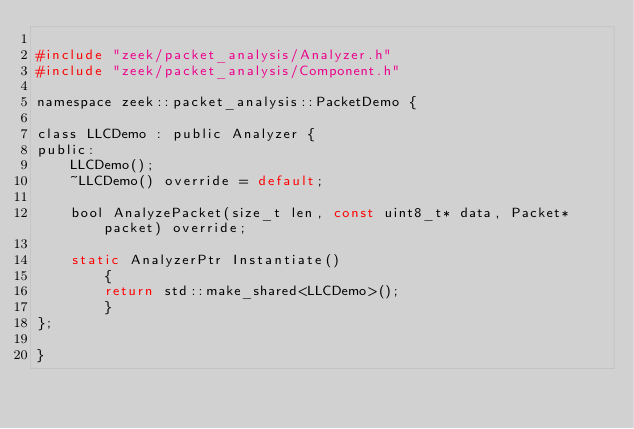Convert code to text. <code><loc_0><loc_0><loc_500><loc_500><_C_>
#include "zeek/packet_analysis/Analyzer.h"
#include "zeek/packet_analysis/Component.h"

namespace zeek::packet_analysis::PacketDemo {

class LLCDemo : public Analyzer {
public:
	LLCDemo();
	~LLCDemo() override = default;

	bool AnalyzePacket(size_t len, const uint8_t* data, Packet* packet) override;

	static AnalyzerPtr Instantiate()
		{
		return std::make_shared<LLCDemo>();
		}
};

}
</code> 